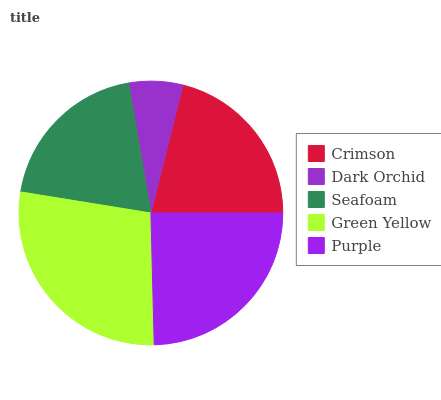Is Dark Orchid the minimum?
Answer yes or no. Yes. Is Green Yellow the maximum?
Answer yes or no. Yes. Is Seafoam the minimum?
Answer yes or no. No. Is Seafoam the maximum?
Answer yes or no. No. Is Seafoam greater than Dark Orchid?
Answer yes or no. Yes. Is Dark Orchid less than Seafoam?
Answer yes or no. Yes. Is Dark Orchid greater than Seafoam?
Answer yes or no. No. Is Seafoam less than Dark Orchid?
Answer yes or no. No. Is Crimson the high median?
Answer yes or no. Yes. Is Crimson the low median?
Answer yes or no. Yes. Is Seafoam the high median?
Answer yes or no. No. Is Seafoam the low median?
Answer yes or no. No. 